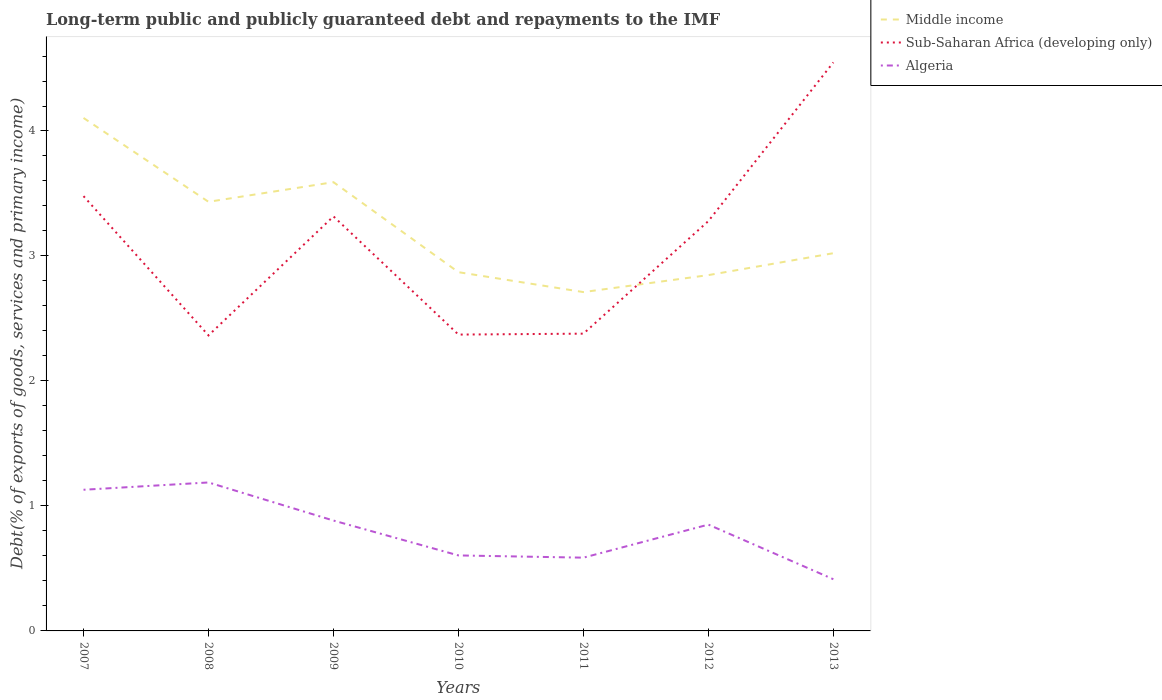How many different coloured lines are there?
Your response must be concise. 3. Does the line corresponding to Sub-Saharan Africa (developing only) intersect with the line corresponding to Middle income?
Keep it short and to the point. Yes. Is the number of lines equal to the number of legend labels?
Your answer should be very brief. Yes. Across all years, what is the maximum debt and repayments in Algeria?
Offer a terse response. 0.41. In which year was the debt and repayments in Algeria maximum?
Offer a very short reply. 2013. What is the total debt and repayments in Sub-Saharan Africa (developing only) in the graph?
Your response must be concise. -2.18. What is the difference between the highest and the second highest debt and repayments in Algeria?
Offer a very short reply. 0.77. How many lines are there?
Your answer should be compact. 3. How many years are there in the graph?
Make the answer very short. 7. What is the difference between two consecutive major ticks on the Y-axis?
Offer a terse response. 1. Are the values on the major ticks of Y-axis written in scientific E-notation?
Your answer should be very brief. No. Does the graph contain any zero values?
Offer a terse response. No. Does the graph contain grids?
Provide a succinct answer. No. How are the legend labels stacked?
Offer a terse response. Vertical. What is the title of the graph?
Offer a terse response. Long-term public and publicly guaranteed debt and repayments to the IMF. What is the label or title of the Y-axis?
Your answer should be very brief. Debt(% of exports of goods, services and primary income). What is the Debt(% of exports of goods, services and primary income) in Middle income in 2007?
Offer a very short reply. 4.1. What is the Debt(% of exports of goods, services and primary income) in Sub-Saharan Africa (developing only) in 2007?
Ensure brevity in your answer.  3.48. What is the Debt(% of exports of goods, services and primary income) of Algeria in 2007?
Your answer should be very brief. 1.13. What is the Debt(% of exports of goods, services and primary income) of Middle income in 2008?
Make the answer very short. 3.43. What is the Debt(% of exports of goods, services and primary income) in Sub-Saharan Africa (developing only) in 2008?
Your answer should be compact. 2.36. What is the Debt(% of exports of goods, services and primary income) in Algeria in 2008?
Your answer should be compact. 1.19. What is the Debt(% of exports of goods, services and primary income) of Middle income in 2009?
Your answer should be very brief. 3.59. What is the Debt(% of exports of goods, services and primary income) in Sub-Saharan Africa (developing only) in 2009?
Offer a very short reply. 3.32. What is the Debt(% of exports of goods, services and primary income) in Algeria in 2009?
Offer a terse response. 0.88. What is the Debt(% of exports of goods, services and primary income) in Middle income in 2010?
Your answer should be compact. 2.87. What is the Debt(% of exports of goods, services and primary income) of Sub-Saharan Africa (developing only) in 2010?
Provide a short and direct response. 2.37. What is the Debt(% of exports of goods, services and primary income) of Algeria in 2010?
Keep it short and to the point. 0.6. What is the Debt(% of exports of goods, services and primary income) in Middle income in 2011?
Your answer should be very brief. 2.71. What is the Debt(% of exports of goods, services and primary income) of Sub-Saharan Africa (developing only) in 2011?
Offer a terse response. 2.38. What is the Debt(% of exports of goods, services and primary income) of Algeria in 2011?
Offer a very short reply. 0.59. What is the Debt(% of exports of goods, services and primary income) of Middle income in 2012?
Make the answer very short. 2.85. What is the Debt(% of exports of goods, services and primary income) of Sub-Saharan Africa (developing only) in 2012?
Give a very brief answer. 3.28. What is the Debt(% of exports of goods, services and primary income) in Algeria in 2012?
Your response must be concise. 0.85. What is the Debt(% of exports of goods, services and primary income) of Middle income in 2013?
Keep it short and to the point. 3.02. What is the Debt(% of exports of goods, services and primary income) in Sub-Saharan Africa (developing only) in 2013?
Your response must be concise. 4.55. What is the Debt(% of exports of goods, services and primary income) in Algeria in 2013?
Provide a succinct answer. 0.41. Across all years, what is the maximum Debt(% of exports of goods, services and primary income) in Middle income?
Make the answer very short. 4.1. Across all years, what is the maximum Debt(% of exports of goods, services and primary income) of Sub-Saharan Africa (developing only)?
Make the answer very short. 4.55. Across all years, what is the maximum Debt(% of exports of goods, services and primary income) of Algeria?
Your response must be concise. 1.19. Across all years, what is the minimum Debt(% of exports of goods, services and primary income) in Middle income?
Keep it short and to the point. 2.71. Across all years, what is the minimum Debt(% of exports of goods, services and primary income) of Sub-Saharan Africa (developing only)?
Offer a terse response. 2.36. Across all years, what is the minimum Debt(% of exports of goods, services and primary income) in Algeria?
Offer a very short reply. 0.41. What is the total Debt(% of exports of goods, services and primary income) in Middle income in the graph?
Your response must be concise. 22.58. What is the total Debt(% of exports of goods, services and primary income) of Sub-Saharan Africa (developing only) in the graph?
Provide a succinct answer. 21.74. What is the total Debt(% of exports of goods, services and primary income) in Algeria in the graph?
Offer a very short reply. 5.66. What is the difference between the Debt(% of exports of goods, services and primary income) of Middle income in 2007 and that in 2008?
Ensure brevity in your answer.  0.67. What is the difference between the Debt(% of exports of goods, services and primary income) in Sub-Saharan Africa (developing only) in 2007 and that in 2008?
Make the answer very short. 1.11. What is the difference between the Debt(% of exports of goods, services and primary income) of Algeria in 2007 and that in 2008?
Give a very brief answer. -0.06. What is the difference between the Debt(% of exports of goods, services and primary income) of Middle income in 2007 and that in 2009?
Offer a terse response. 0.51. What is the difference between the Debt(% of exports of goods, services and primary income) of Sub-Saharan Africa (developing only) in 2007 and that in 2009?
Provide a succinct answer. 0.16. What is the difference between the Debt(% of exports of goods, services and primary income) of Algeria in 2007 and that in 2009?
Offer a terse response. 0.25. What is the difference between the Debt(% of exports of goods, services and primary income) of Middle income in 2007 and that in 2010?
Give a very brief answer. 1.23. What is the difference between the Debt(% of exports of goods, services and primary income) in Sub-Saharan Africa (developing only) in 2007 and that in 2010?
Offer a very short reply. 1.11. What is the difference between the Debt(% of exports of goods, services and primary income) of Algeria in 2007 and that in 2010?
Keep it short and to the point. 0.53. What is the difference between the Debt(% of exports of goods, services and primary income) in Middle income in 2007 and that in 2011?
Provide a succinct answer. 1.39. What is the difference between the Debt(% of exports of goods, services and primary income) in Sub-Saharan Africa (developing only) in 2007 and that in 2011?
Provide a short and direct response. 1.1. What is the difference between the Debt(% of exports of goods, services and primary income) in Algeria in 2007 and that in 2011?
Offer a very short reply. 0.54. What is the difference between the Debt(% of exports of goods, services and primary income) of Middle income in 2007 and that in 2012?
Offer a terse response. 1.26. What is the difference between the Debt(% of exports of goods, services and primary income) in Sub-Saharan Africa (developing only) in 2007 and that in 2012?
Ensure brevity in your answer.  0.2. What is the difference between the Debt(% of exports of goods, services and primary income) in Algeria in 2007 and that in 2012?
Ensure brevity in your answer.  0.28. What is the difference between the Debt(% of exports of goods, services and primary income) in Middle income in 2007 and that in 2013?
Provide a succinct answer. 1.08. What is the difference between the Debt(% of exports of goods, services and primary income) in Sub-Saharan Africa (developing only) in 2007 and that in 2013?
Make the answer very short. -1.07. What is the difference between the Debt(% of exports of goods, services and primary income) of Algeria in 2007 and that in 2013?
Make the answer very short. 0.72. What is the difference between the Debt(% of exports of goods, services and primary income) in Middle income in 2008 and that in 2009?
Your response must be concise. -0.16. What is the difference between the Debt(% of exports of goods, services and primary income) in Sub-Saharan Africa (developing only) in 2008 and that in 2009?
Your response must be concise. -0.95. What is the difference between the Debt(% of exports of goods, services and primary income) in Algeria in 2008 and that in 2009?
Your response must be concise. 0.3. What is the difference between the Debt(% of exports of goods, services and primary income) of Middle income in 2008 and that in 2010?
Your response must be concise. 0.56. What is the difference between the Debt(% of exports of goods, services and primary income) in Sub-Saharan Africa (developing only) in 2008 and that in 2010?
Keep it short and to the point. -0.01. What is the difference between the Debt(% of exports of goods, services and primary income) of Algeria in 2008 and that in 2010?
Offer a very short reply. 0.58. What is the difference between the Debt(% of exports of goods, services and primary income) of Middle income in 2008 and that in 2011?
Your response must be concise. 0.72. What is the difference between the Debt(% of exports of goods, services and primary income) in Sub-Saharan Africa (developing only) in 2008 and that in 2011?
Your answer should be very brief. -0.01. What is the difference between the Debt(% of exports of goods, services and primary income) in Algeria in 2008 and that in 2011?
Make the answer very short. 0.6. What is the difference between the Debt(% of exports of goods, services and primary income) of Middle income in 2008 and that in 2012?
Your answer should be very brief. 0.59. What is the difference between the Debt(% of exports of goods, services and primary income) in Sub-Saharan Africa (developing only) in 2008 and that in 2012?
Make the answer very short. -0.91. What is the difference between the Debt(% of exports of goods, services and primary income) of Algeria in 2008 and that in 2012?
Make the answer very short. 0.34. What is the difference between the Debt(% of exports of goods, services and primary income) in Middle income in 2008 and that in 2013?
Your response must be concise. 0.41. What is the difference between the Debt(% of exports of goods, services and primary income) in Sub-Saharan Africa (developing only) in 2008 and that in 2013?
Provide a succinct answer. -2.18. What is the difference between the Debt(% of exports of goods, services and primary income) in Algeria in 2008 and that in 2013?
Keep it short and to the point. 0.77. What is the difference between the Debt(% of exports of goods, services and primary income) of Middle income in 2009 and that in 2010?
Provide a short and direct response. 0.72. What is the difference between the Debt(% of exports of goods, services and primary income) in Sub-Saharan Africa (developing only) in 2009 and that in 2010?
Offer a very short reply. 0.95. What is the difference between the Debt(% of exports of goods, services and primary income) of Algeria in 2009 and that in 2010?
Give a very brief answer. 0.28. What is the difference between the Debt(% of exports of goods, services and primary income) of Middle income in 2009 and that in 2011?
Offer a very short reply. 0.88. What is the difference between the Debt(% of exports of goods, services and primary income) of Sub-Saharan Africa (developing only) in 2009 and that in 2011?
Make the answer very short. 0.94. What is the difference between the Debt(% of exports of goods, services and primary income) in Algeria in 2009 and that in 2011?
Your answer should be very brief. 0.3. What is the difference between the Debt(% of exports of goods, services and primary income) of Middle income in 2009 and that in 2012?
Keep it short and to the point. 0.74. What is the difference between the Debt(% of exports of goods, services and primary income) of Sub-Saharan Africa (developing only) in 2009 and that in 2012?
Offer a very short reply. 0.04. What is the difference between the Debt(% of exports of goods, services and primary income) of Algeria in 2009 and that in 2012?
Ensure brevity in your answer.  0.03. What is the difference between the Debt(% of exports of goods, services and primary income) of Middle income in 2009 and that in 2013?
Your answer should be very brief. 0.57. What is the difference between the Debt(% of exports of goods, services and primary income) of Sub-Saharan Africa (developing only) in 2009 and that in 2013?
Your response must be concise. -1.23. What is the difference between the Debt(% of exports of goods, services and primary income) of Algeria in 2009 and that in 2013?
Ensure brevity in your answer.  0.47. What is the difference between the Debt(% of exports of goods, services and primary income) of Middle income in 2010 and that in 2011?
Offer a very short reply. 0.16. What is the difference between the Debt(% of exports of goods, services and primary income) in Sub-Saharan Africa (developing only) in 2010 and that in 2011?
Keep it short and to the point. -0.01. What is the difference between the Debt(% of exports of goods, services and primary income) of Algeria in 2010 and that in 2011?
Provide a succinct answer. 0.02. What is the difference between the Debt(% of exports of goods, services and primary income) in Middle income in 2010 and that in 2012?
Your answer should be very brief. 0.02. What is the difference between the Debt(% of exports of goods, services and primary income) of Sub-Saharan Africa (developing only) in 2010 and that in 2012?
Keep it short and to the point. -0.91. What is the difference between the Debt(% of exports of goods, services and primary income) in Algeria in 2010 and that in 2012?
Provide a succinct answer. -0.25. What is the difference between the Debt(% of exports of goods, services and primary income) of Middle income in 2010 and that in 2013?
Provide a short and direct response. -0.15. What is the difference between the Debt(% of exports of goods, services and primary income) of Sub-Saharan Africa (developing only) in 2010 and that in 2013?
Your answer should be very brief. -2.18. What is the difference between the Debt(% of exports of goods, services and primary income) of Algeria in 2010 and that in 2013?
Provide a succinct answer. 0.19. What is the difference between the Debt(% of exports of goods, services and primary income) in Middle income in 2011 and that in 2012?
Keep it short and to the point. -0.14. What is the difference between the Debt(% of exports of goods, services and primary income) in Sub-Saharan Africa (developing only) in 2011 and that in 2012?
Offer a terse response. -0.9. What is the difference between the Debt(% of exports of goods, services and primary income) of Algeria in 2011 and that in 2012?
Ensure brevity in your answer.  -0.26. What is the difference between the Debt(% of exports of goods, services and primary income) in Middle income in 2011 and that in 2013?
Provide a short and direct response. -0.31. What is the difference between the Debt(% of exports of goods, services and primary income) of Sub-Saharan Africa (developing only) in 2011 and that in 2013?
Your response must be concise. -2.17. What is the difference between the Debt(% of exports of goods, services and primary income) of Algeria in 2011 and that in 2013?
Give a very brief answer. 0.17. What is the difference between the Debt(% of exports of goods, services and primary income) of Middle income in 2012 and that in 2013?
Your answer should be compact. -0.18. What is the difference between the Debt(% of exports of goods, services and primary income) in Sub-Saharan Africa (developing only) in 2012 and that in 2013?
Ensure brevity in your answer.  -1.27. What is the difference between the Debt(% of exports of goods, services and primary income) in Algeria in 2012 and that in 2013?
Your response must be concise. 0.44. What is the difference between the Debt(% of exports of goods, services and primary income) of Middle income in 2007 and the Debt(% of exports of goods, services and primary income) of Sub-Saharan Africa (developing only) in 2008?
Your response must be concise. 1.74. What is the difference between the Debt(% of exports of goods, services and primary income) in Middle income in 2007 and the Debt(% of exports of goods, services and primary income) in Algeria in 2008?
Your answer should be compact. 2.92. What is the difference between the Debt(% of exports of goods, services and primary income) of Sub-Saharan Africa (developing only) in 2007 and the Debt(% of exports of goods, services and primary income) of Algeria in 2008?
Make the answer very short. 2.29. What is the difference between the Debt(% of exports of goods, services and primary income) of Middle income in 2007 and the Debt(% of exports of goods, services and primary income) of Sub-Saharan Africa (developing only) in 2009?
Ensure brevity in your answer.  0.79. What is the difference between the Debt(% of exports of goods, services and primary income) in Middle income in 2007 and the Debt(% of exports of goods, services and primary income) in Algeria in 2009?
Keep it short and to the point. 3.22. What is the difference between the Debt(% of exports of goods, services and primary income) in Sub-Saharan Africa (developing only) in 2007 and the Debt(% of exports of goods, services and primary income) in Algeria in 2009?
Your answer should be compact. 2.6. What is the difference between the Debt(% of exports of goods, services and primary income) in Middle income in 2007 and the Debt(% of exports of goods, services and primary income) in Sub-Saharan Africa (developing only) in 2010?
Your response must be concise. 1.73. What is the difference between the Debt(% of exports of goods, services and primary income) of Middle income in 2007 and the Debt(% of exports of goods, services and primary income) of Algeria in 2010?
Offer a terse response. 3.5. What is the difference between the Debt(% of exports of goods, services and primary income) in Sub-Saharan Africa (developing only) in 2007 and the Debt(% of exports of goods, services and primary income) in Algeria in 2010?
Your response must be concise. 2.87. What is the difference between the Debt(% of exports of goods, services and primary income) of Middle income in 2007 and the Debt(% of exports of goods, services and primary income) of Sub-Saharan Africa (developing only) in 2011?
Your answer should be very brief. 1.73. What is the difference between the Debt(% of exports of goods, services and primary income) of Middle income in 2007 and the Debt(% of exports of goods, services and primary income) of Algeria in 2011?
Provide a short and direct response. 3.52. What is the difference between the Debt(% of exports of goods, services and primary income) of Sub-Saharan Africa (developing only) in 2007 and the Debt(% of exports of goods, services and primary income) of Algeria in 2011?
Give a very brief answer. 2.89. What is the difference between the Debt(% of exports of goods, services and primary income) of Middle income in 2007 and the Debt(% of exports of goods, services and primary income) of Sub-Saharan Africa (developing only) in 2012?
Provide a succinct answer. 0.83. What is the difference between the Debt(% of exports of goods, services and primary income) of Middle income in 2007 and the Debt(% of exports of goods, services and primary income) of Algeria in 2012?
Keep it short and to the point. 3.25. What is the difference between the Debt(% of exports of goods, services and primary income) of Sub-Saharan Africa (developing only) in 2007 and the Debt(% of exports of goods, services and primary income) of Algeria in 2012?
Your response must be concise. 2.63. What is the difference between the Debt(% of exports of goods, services and primary income) in Middle income in 2007 and the Debt(% of exports of goods, services and primary income) in Sub-Saharan Africa (developing only) in 2013?
Give a very brief answer. -0.44. What is the difference between the Debt(% of exports of goods, services and primary income) of Middle income in 2007 and the Debt(% of exports of goods, services and primary income) of Algeria in 2013?
Ensure brevity in your answer.  3.69. What is the difference between the Debt(% of exports of goods, services and primary income) of Sub-Saharan Africa (developing only) in 2007 and the Debt(% of exports of goods, services and primary income) of Algeria in 2013?
Provide a succinct answer. 3.07. What is the difference between the Debt(% of exports of goods, services and primary income) in Middle income in 2008 and the Debt(% of exports of goods, services and primary income) in Sub-Saharan Africa (developing only) in 2009?
Give a very brief answer. 0.12. What is the difference between the Debt(% of exports of goods, services and primary income) of Middle income in 2008 and the Debt(% of exports of goods, services and primary income) of Algeria in 2009?
Offer a very short reply. 2.55. What is the difference between the Debt(% of exports of goods, services and primary income) of Sub-Saharan Africa (developing only) in 2008 and the Debt(% of exports of goods, services and primary income) of Algeria in 2009?
Offer a terse response. 1.48. What is the difference between the Debt(% of exports of goods, services and primary income) of Middle income in 2008 and the Debt(% of exports of goods, services and primary income) of Sub-Saharan Africa (developing only) in 2010?
Ensure brevity in your answer.  1.06. What is the difference between the Debt(% of exports of goods, services and primary income) of Middle income in 2008 and the Debt(% of exports of goods, services and primary income) of Algeria in 2010?
Your response must be concise. 2.83. What is the difference between the Debt(% of exports of goods, services and primary income) in Sub-Saharan Africa (developing only) in 2008 and the Debt(% of exports of goods, services and primary income) in Algeria in 2010?
Provide a short and direct response. 1.76. What is the difference between the Debt(% of exports of goods, services and primary income) of Middle income in 2008 and the Debt(% of exports of goods, services and primary income) of Sub-Saharan Africa (developing only) in 2011?
Offer a terse response. 1.05. What is the difference between the Debt(% of exports of goods, services and primary income) of Middle income in 2008 and the Debt(% of exports of goods, services and primary income) of Algeria in 2011?
Make the answer very short. 2.85. What is the difference between the Debt(% of exports of goods, services and primary income) in Sub-Saharan Africa (developing only) in 2008 and the Debt(% of exports of goods, services and primary income) in Algeria in 2011?
Your answer should be very brief. 1.78. What is the difference between the Debt(% of exports of goods, services and primary income) of Middle income in 2008 and the Debt(% of exports of goods, services and primary income) of Sub-Saharan Africa (developing only) in 2012?
Ensure brevity in your answer.  0.15. What is the difference between the Debt(% of exports of goods, services and primary income) of Middle income in 2008 and the Debt(% of exports of goods, services and primary income) of Algeria in 2012?
Provide a short and direct response. 2.58. What is the difference between the Debt(% of exports of goods, services and primary income) of Sub-Saharan Africa (developing only) in 2008 and the Debt(% of exports of goods, services and primary income) of Algeria in 2012?
Your answer should be very brief. 1.51. What is the difference between the Debt(% of exports of goods, services and primary income) of Middle income in 2008 and the Debt(% of exports of goods, services and primary income) of Sub-Saharan Africa (developing only) in 2013?
Your response must be concise. -1.12. What is the difference between the Debt(% of exports of goods, services and primary income) of Middle income in 2008 and the Debt(% of exports of goods, services and primary income) of Algeria in 2013?
Keep it short and to the point. 3.02. What is the difference between the Debt(% of exports of goods, services and primary income) of Sub-Saharan Africa (developing only) in 2008 and the Debt(% of exports of goods, services and primary income) of Algeria in 2013?
Keep it short and to the point. 1.95. What is the difference between the Debt(% of exports of goods, services and primary income) in Middle income in 2009 and the Debt(% of exports of goods, services and primary income) in Sub-Saharan Africa (developing only) in 2010?
Your response must be concise. 1.22. What is the difference between the Debt(% of exports of goods, services and primary income) of Middle income in 2009 and the Debt(% of exports of goods, services and primary income) of Algeria in 2010?
Give a very brief answer. 2.99. What is the difference between the Debt(% of exports of goods, services and primary income) of Sub-Saharan Africa (developing only) in 2009 and the Debt(% of exports of goods, services and primary income) of Algeria in 2010?
Your answer should be compact. 2.71. What is the difference between the Debt(% of exports of goods, services and primary income) in Middle income in 2009 and the Debt(% of exports of goods, services and primary income) in Sub-Saharan Africa (developing only) in 2011?
Your answer should be compact. 1.21. What is the difference between the Debt(% of exports of goods, services and primary income) of Middle income in 2009 and the Debt(% of exports of goods, services and primary income) of Algeria in 2011?
Offer a terse response. 3. What is the difference between the Debt(% of exports of goods, services and primary income) in Sub-Saharan Africa (developing only) in 2009 and the Debt(% of exports of goods, services and primary income) in Algeria in 2011?
Your answer should be compact. 2.73. What is the difference between the Debt(% of exports of goods, services and primary income) of Middle income in 2009 and the Debt(% of exports of goods, services and primary income) of Sub-Saharan Africa (developing only) in 2012?
Ensure brevity in your answer.  0.31. What is the difference between the Debt(% of exports of goods, services and primary income) in Middle income in 2009 and the Debt(% of exports of goods, services and primary income) in Algeria in 2012?
Keep it short and to the point. 2.74. What is the difference between the Debt(% of exports of goods, services and primary income) of Sub-Saharan Africa (developing only) in 2009 and the Debt(% of exports of goods, services and primary income) of Algeria in 2012?
Ensure brevity in your answer.  2.47. What is the difference between the Debt(% of exports of goods, services and primary income) of Middle income in 2009 and the Debt(% of exports of goods, services and primary income) of Sub-Saharan Africa (developing only) in 2013?
Ensure brevity in your answer.  -0.96. What is the difference between the Debt(% of exports of goods, services and primary income) of Middle income in 2009 and the Debt(% of exports of goods, services and primary income) of Algeria in 2013?
Provide a short and direct response. 3.18. What is the difference between the Debt(% of exports of goods, services and primary income) in Sub-Saharan Africa (developing only) in 2009 and the Debt(% of exports of goods, services and primary income) in Algeria in 2013?
Your answer should be compact. 2.9. What is the difference between the Debt(% of exports of goods, services and primary income) of Middle income in 2010 and the Debt(% of exports of goods, services and primary income) of Sub-Saharan Africa (developing only) in 2011?
Your response must be concise. 0.49. What is the difference between the Debt(% of exports of goods, services and primary income) in Middle income in 2010 and the Debt(% of exports of goods, services and primary income) in Algeria in 2011?
Offer a very short reply. 2.28. What is the difference between the Debt(% of exports of goods, services and primary income) of Sub-Saharan Africa (developing only) in 2010 and the Debt(% of exports of goods, services and primary income) of Algeria in 2011?
Your response must be concise. 1.78. What is the difference between the Debt(% of exports of goods, services and primary income) in Middle income in 2010 and the Debt(% of exports of goods, services and primary income) in Sub-Saharan Africa (developing only) in 2012?
Provide a short and direct response. -0.41. What is the difference between the Debt(% of exports of goods, services and primary income) of Middle income in 2010 and the Debt(% of exports of goods, services and primary income) of Algeria in 2012?
Your response must be concise. 2.02. What is the difference between the Debt(% of exports of goods, services and primary income) in Sub-Saharan Africa (developing only) in 2010 and the Debt(% of exports of goods, services and primary income) in Algeria in 2012?
Your answer should be very brief. 1.52. What is the difference between the Debt(% of exports of goods, services and primary income) in Middle income in 2010 and the Debt(% of exports of goods, services and primary income) in Sub-Saharan Africa (developing only) in 2013?
Make the answer very short. -1.68. What is the difference between the Debt(% of exports of goods, services and primary income) of Middle income in 2010 and the Debt(% of exports of goods, services and primary income) of Algeria in 2013?
Make the answer very short. 2.46. What is the difference between the Debt(% of exports of goods, services and primary income) of Sub-Saharan Africa (developing only) in 2010 and the Debt(% of exports of goods, services and primary income) of Algeria in 2013?
Your answer should be compact. 1.96. What is the difference between the Debt(% of exports of goods, services and primary income) in Middle income in 2011 and the Debt(% of exports of goods, services and primary income) in Sub-Saharan Africa (developing only) in 2012?
Your answer should be very brief. -0.57. What is the difference between the Debt(% of exports of goods, services and primary income) in Middle income in 2011 and the Debt(% of exports of goods, services and primary income) in Algeria in 2012?
Offer a terse response. 1.86. What is the difference between the Debt(% of exports of goods, services and primary income) in Sub-Saharan Africa (developing only) in 2011 and the Debt(% of exports of goods, services and primary income) in Algeria in 2012?
Provide a short and direct response. 1.53. What is the difference between the Debt(% of exports of goods, services and primary income) in Middle income in 2011 and the Debt(% of exports of goods, services and primary income) in Sub-Saharan Africa (developing only) in 2013?
Offer a very short reply. -1.84. What is the difference between the Debt(% of exports of goods, services and primary income) in Middle income in 2011 and the Debt(% of exports of goods, services and primary income) in Algeria in 2013?
Provide a short and direct response. 2.3. What is the difference between the Debt(% of exports of goods, services and primary income) in Sub-Saharan Africa (developing only) in 2011 and the Debt(% of exports of goods, services and primary income) in Algeria in 2013?
Make the answer very short. 1.96. What is the difference between the Debt(% of exports of goods, services and primary income) in Middle income in 2012 and the Debt(% of exports of goods, services and primary income) in Sub-Saharan Africa (developing only) in 2013?
Ensure brevity in your answer.  -1.7. What is the difference between the Debt(% of exports of goods, services and primary income) of Middle income in 2012 and the Debt(% of exports of goods, services and primary income) of Algeria in 2013?
Provide a succinct answer. 2.43. What is the difference between the Debt(% of exports of goods, services and primary income) of Sub-Saharan Africa (developing only) in 2012 and the Debt(% of exports of goods, services and primary income) of Algeria in 2013?
Keep it short and to the point. 2.87. What is the average Debt(% of exports of goods, services and primary income) of Middle income per year?
Ensure brevity in your answer.  3.23. What is the average Debt(% of exports of goods, services and primary income) in Sub-Saharan Africa (developing only) per year?
Ensure brevity in your answer.  3.11. What is the average Debt(% of exports of goods, services and primary income) in Algeria per year?
Ensure brevity in your answer.  0.81. In the year 2007, what is the difference between the Debt(% of exports of goods, services and primary income) in Middle income and Debt(% of exports of goods, services and primary income) in Sub-Saharan Africa (developing only)?
Ensure brevity in your answer.  0.63. In the year 2007, what is the difference between the Debt(% of exports of goods, services and primary income) of Middle income and Debt(% of exports of goods, services and primary income) of Algeria?
Your answer should be compact. 2.97. In the year 2007, what is the difference between the Debt(% of exports of goods, services and primary income) of Sub-Saharan Africa (developing only) and Debt(% of exports of goods, services and primary income) of Algeria?
Offer a terse response. 2.35. In the year 2008, what is the difference between the Debt(% of exports of goods, services and primary income) of Middle income and Debt(% of exports of goods, services and primary income) of Sub-Saharan Africa (developing only)?
Make the answer very short. 1.07. In the year 2008, what is the difference between the Debt(% of exports of goods, services and primary income) in Middle income and Debt(% of exports of goods, services and primary income) in Algeria?
Your answer should be very brief. 2.25. In the year 2008, what is the difference between the Debt(% of exports of goods, services and primary income) of Sub-Saharan Africa (developing only) and Debt(% of exports of goods, services and primary income) of Algeria?
Make the answer very short. 1.18. In the year 2009, what is the difference between the Debt(% of exports of goods, services and primary income) of Middle income and Debt(% of exports of goods, services and primary income) of Sub-Saharan Africa (developing only)?
Make the answer very short. 0.27. In the year 2009, what is the difference between the Debt(% of exports of goods, services and primary income) in Middle income and Debt(% of exports of goods, services and primary income) in Algeria?
Give a very brief answer. 2.71. In the year 2009, what is the difference between the Debt(% of exports of goods, services and primary income) of Sub-Saharan Africa (developing only) and Debt(% of exports of goods, services and primary income) of Algeria?
Offer a terse response. 2.43. In the year 2010, what is the difference between the Debt(% of exports of goods, services and primary income) of Middle income and Debt(% of exports of goods, services and primary income) of Sub-Saharan Africa (developing only)?
Ensure brevity in your answer.  0.5. In the year 2010, what is the difference between the Debt(% of exports of goods, services and primary income) of Middle income and Debt(% of exports of goods, services and primary income) of Algeria?
Your answer should be very brief. 2.27. In the year 2010, what is the difference between the Debt(% of exports of goods, services and primary income) in Sub-Saharan Africa (developing only) and Debt(% of exports of goods, services and primary income) in Algeria?
Offer a very short reply. 1.77. In the year 2011, what is the difference between the Debt(% of exports of goods, services and primary income) in Middle income and Debt(% of exports of goods, services and primary income) in Sub-Saharan Africa (developing only)?
Offer a very short reply. 0.33. In the year 2011, what is the difference between the Debt(% of exports of goods, services and primary income) in Middle income and Debt(% of exports of goods, services and primary income) in Algeria?
Give a very brief answer. 2.12. In the year 2011, what is the difference between the Debt(% of exports of goods, services and primary income) in Sub-Saharan Africa (developing only) and Debt(% of exports of goods, services and primary income) in Algeria?
Provide a succinct answer. 1.79. In the year 2012, what is the difference between the Debt(% of exports of goods, services and primary income) of Middle income and Debt(% of exports of goods, services and primary income) of Sub-Saharan Africa (developing only)?
Offer a very short reply. -0.43. In the year 2012, what is the difference between the Debt(% of exports of goods, services and primary income) of Middle income and Debt(% of exports of goods, services and primary income) of Algeria?
Your response must be concise. 2. In the year 2012, what is the difference between the Debt(% of exports of goods, services and primary income) of Sub-Saharan Africa (developing only) and Debt(% of exports of goods, services and primary income) of Algeria?
Offer a very short reply. 2.43. In the year 2013, what is the difference between the Debt(% of exports of goods, services and primary income) in Middle income and Debt(% of exports of goods, services and primary income) in Sub-Saharan Africa (developing only)?
Your answer should be very brief. -1.53. In the year 2013, what is the difference between the Debt(% of exports of goods, services and primary income) of Middle income and Debt(% of exports of goods, services and primary income) of Algeria?
Give a very brief answer. 2.61. In the year 2013, what is the difference between the Debt(% of exports of goods, services and primary income) of Sub-Saharan Africa (developing only) and Debt(% of exports of goods, services and primary income) of Algeria?
Offer a very short reply. 4.14. What is the ratio of the Debt(% of exports of goods, services and primary income) of Middle income in 2007 to that in 2008?
Ensure brevity in your answer.  1.2. What is the ratio of the Debt(% of exports of goods, services and primary income) of Sub-Saharan Africa (developing only) in 2007 to that in 2008?
Offer a terse response. 1.47. What is the ratio of the Debt(% of exports of goods, services and primary income) in Algeria in 2007 to that in 2008?
Keep it short and to the point. 0.95. What is the ratio of the Debt(% of exports of goods, services and primary income) of Middle income in 2007 to that in 2009?
Give a very brief answer. 1.14. What is the ratio of the Debt(% of exports of goods, services and primary income) of Sub-Saharan Africa (developing only) in 2007 to that in 2009?
Your response must be concise. 1.05. What is the ratio of the Debt(% of exports of goods, services and primary income) in Algeria in 2007 to that in 2009?
Your answer should be very brief. 1.28. What is the ratio of the Debt(% of exports of goods, services and primary income) of Middle income in 2007 to that in 2010?
Your answer should be very brief. 1.43. What is the ratio of the Debt(% of exports of goods, services and primary income) of Sub-Saharan Africa (developing only) in 2007 to that in 2010?
Your answer should be compact. 1.47. What is the ratio of the Debt(% of exports of goods, services and primary income) of Algeria in 2007 to that in 2010?
Give a very brief answer. 1.87. What is the ratio of the Debt(% of exports of goods, services and primary income) in Middle income in 2007 to that in 2011?
Your response must be concise. 1.51. What is the ratio of the Debt(% of exports of goods, services and primary income) of Sub-Saharan Africa (developing only) in 2007 to that in 2011?
Offer a very short reply. 1.46. What is the ratio of the Debt(% of exports of goods, services and primary income) in Algeria in 2007 to that in 2011?
Offer a terse response. 1.93. What is the ratio of the Debt(% of exports of goods, services and primary income) of Middle income in 2007 to that in 2012?
Offer a terse response. 1.44. What is the ratio of the Debt(% of exports of goods, services and primary income) in Sub-Saharan Africa (developing only) in 2007 to that in 2012?
Ensure brevity in your answer.  1.06. What is the ratio of the Debt(% of exports of goods, services and primary income) in Algeria in 2007 to that in 2012?
Keep it short and to the point. 1.33. What is the ratio of the Debt(% of exports of goods, services and primary income) of Middle income in 2007 to that in 2013?
Give a very brief answer. 1.36. What is the ratio of the Debt(% of exports of goods, services and primary income) in Sub-Saharan Africa (developing only) in 2007 to that in 2013?
Your answer should be compact. 0.76. What is the ratio of the Debt(% of exports of goods, services and primary income) of Algeria in 2007 to that in 2013?
Ensure brevity in your answer.  2.73. What is the ratio of the Debt(% of exports of goods, services and primary income) in Middle income in 2008 to that in 2009?
Make the answer very short. 0.96. What is the ratio of the Debt(% of exports of goods, services and primary income) of Sub-Saharan Africa (developing only) in 2008 to that in 2009?
Provide a short and direct response. 0.71. What is the ratio of the Debt(% of exports of goods, services and primary income) in Algeria in 2008 to that in 2009?
Provide a succinct answer. 1.35. What is the ratio of the Debt(% of exports of goods, services and primary income) of Middle income in 2008 to that in 2010?
Give a very brief answer. 1.2. What is the ratio of the Debt(% of exports of goods, services and primary income) in Algeria in 2008 to that in 2010?
Offer a very short reply. 1.97. What is the ratio of the Debt(% of exports of goods, services and primary income) in Middle income in 2008 to that in 2011?
Ensure brevity in your answer.  1.27. What is the ratio of the Debt(% of exports of goods, services and primary income) in Algeria in 2008 to that in 2011?
Provide a short and direct response. 2.03. What is the ratio of the Debt(% of exports of goods, services and primary income) in Middle income in 2008 to that in 2012?
Ensure brevity in your answer.  1.21. What is the ratio of the Debt(% of exports of goods, services and primary income) in Sub-Saharan Africa (developing only) in 2008 to that in 2012?
Your answer should be compact. 0.72. What is the ratio of the Debt(% of exports of goods, services and primary income) in Algeria in 2008 to that in 2012?
Make the answer very short. 1.4. What is the ratio of the Debt(% of exports of goods, services and primary income) of Middle income in 2008 to that in 2013?
Offer a terse response. 1.14. What is the ratio of the Debt(% of exports of goods, services and primary income) of Sub-Saharan Africa (developing only) in 2008 to that in 2013?
Offer a very short reply. 0.52. What is the ratio of the Debt(% of exports of goods, services and primary income) of Algeria in 2008 to that in 2013?
Your answer should be compact. 2.87. What is the ratio of the Debt(% of exports of goods, services and primary income) in Middle income in 2009 to that in 2010?
Make the answer very short. 1.25. What is the ratio of the Debt(% of exports of goods, services and primary income) in Sub-Saharan Africa (developing only) in 2009 to that in 2010?
Ensure brevity in your answer.  1.4. What is the ratio of the Debt(% of exports of goods, services and primary income) of Algeria in 2009 to that in 2010?
Your response must be concise. 1.46. What is the ratio of the Debt(% of exports of goods, services and primary income) in Middle income in 2009 to that in 2011?
Offer a very short reply. 1.32. What is the ratio of the Debt(% of exports of goods, services and primary income) of Sub-Saharan Africa (developing only) in 2009 to that in 2011?
Your answer should be compact. 1.39. What is the ratio of the Debt(% of exports of goods, services and primary income) in Algeria in 2009 to that in 2011?
Offer a very short reply. 1.51. What is the ratio of the Debt(% of exports of goods, services and primary income) in Middle income in 2009 to that in 2012?
Your answer should be very brief. 1.26. What is the ratio of the Debt(% of exports of goods, services and primary income) of Sub-Saharan Africa (developing only) in 2009 to that in 2012?
Provide a succinct answer. 1.01. What is the ratio of the Debt(% of exports of goods, services and primary income) in Algeria in 2009 to that in 2012?
Keep it short and to the point. 1.04. What is the ratio of the Debt(% of exports of goods, services and primary income) of Middle income in 2009 to that in 2013?
Ensure brevity in your answer.  1.19. What is the ratio of the Debt(% of exports of goods, services and primary income) of Sub-Saharan Africa (developing only) in 2009 to that in 2013?
Your response must be concise. 0.73. What is the ratio of the Debt(% of exports of goods, services and primary income) in Algeria in 2009 to that in 2013?
Your answer should be very brief. 2.14. What is the ratio of the Debt(% of exports of goods, services and primary income) of Middle income in 2010 to that in 2011?
Your response must be concise. 1.06. What is the ratio of the Debt(% of exports of goods, services and primary income) of Algeria in 2010 to that in 2011?
Ensure brevity in your answer.  1.03. What is the ratio of the Debt(% of exports of goods, services and primary income) of Middle income in 2010 to that in 2012?
Your answer should be compact. 1.01. What is the ratio of the Debt(% of exports of goods, services and primary income) in Sub-Saharan Africa (developing only) in 2010 to that in 2012?
Offer a terse response. 0.72. What is the ratio of the Debt(% of exports of goods, services and primary income) in Algeria in 2010 to that in 2012?
Provide a short and direct response. 0.71. What is the ratio of the Debt(% of exports of goods, services and primary income) in Middle income in 2010 to that in 2013?
Your answer should be very brief. 0.95. What is the ratio of the Debt(% of exports of goods, services and primary income) of Sub-Saharan Africa (developing only) in 2010 to that in 2013?
Your response must be concise. 0.52. What is the ratio of the Debt(% of exports of goods, services and primary income) in Algeria in 2010 to that in 2013?
Ensure brevity in your answer.  1.46. What is the ratio of the Debt(% of exports of goods, services and primary income) of Middle income in 2011 to that in 2012?
Your answer should be very brief. 0.95. What is the ratio of the Debt(% of exports of goods, services and primary income) in Sub-Saharan Africa (developing only) in 2011 to that in 2012?
Offer a very short reply. 0.73. What is the ratio of the Debt(% of exports of goods, services and primary income) of Algeria in 2011 to that in 2012?
Ensure brevity in your answer.  0.69. What is the ratio of the Debt(% of exports of goods, services and primary income) of Middle income in 2011 to that in 2013?
Offer a very short reply. 0.9. What is the ratio of the Debt(% of exports of goods, services and primary income) of Sub-Saharan Africa (developing only) in 2011 to that in 2013?
Offer a very short reply. 0.52. What is the ratio of the Debt(% of exports of goods, services and primary income) of Algeria in 2011 to that in 2013?
Offer a terse response. 1.42. What is the ratio of the Debt(% of exports of goods, services and primary income) of Middle income in 2012 to that in 2013?
Provide a succinct answer. 0.94. What is the ratio of the Debt(% of exports of goods, services and primary income) of Sub-Saharan Africa (developing only) in 2012 to that in 2013?
Provide a succinct answer. 0.72. What is the ratio of the Debt(% of exports of goods, services and primary income) of Algeria in 2012 to that in 2013?
Your answer should be compact. 2.06. What is the difference between the highest and the second highest Debt(% of exports of goods, services and primary income) in Middle income?
Give a very brief answer. 0.51. What is the difference between the highest and the second highest Debt(% of exports of goods, services and primary income) of Sub-Saharan Africa (developing only)?
Your answer should be compact. 1.07. What is the difference between the highest and the second highest Debt(% of exports of goods, services and primary income) of Algeria?
Provide a short and direct response. 0.06. What is the difference between the highest and the lowest Debt(% of exports of goods, services and primary income) of Middle income?
Provide a succinct answer. 1.39. What is the difference between the highest and the lowest Debt(% of exports of goods, services and primary income) in Sub-Saharan Africa (developing only)?
Provide a short and direct response. 2.18. What is the difference between the highest and the lowest Debt(% of exports of goods, services and primary income) of Algeria?
Ensure brevity in your answer.  0.77. 